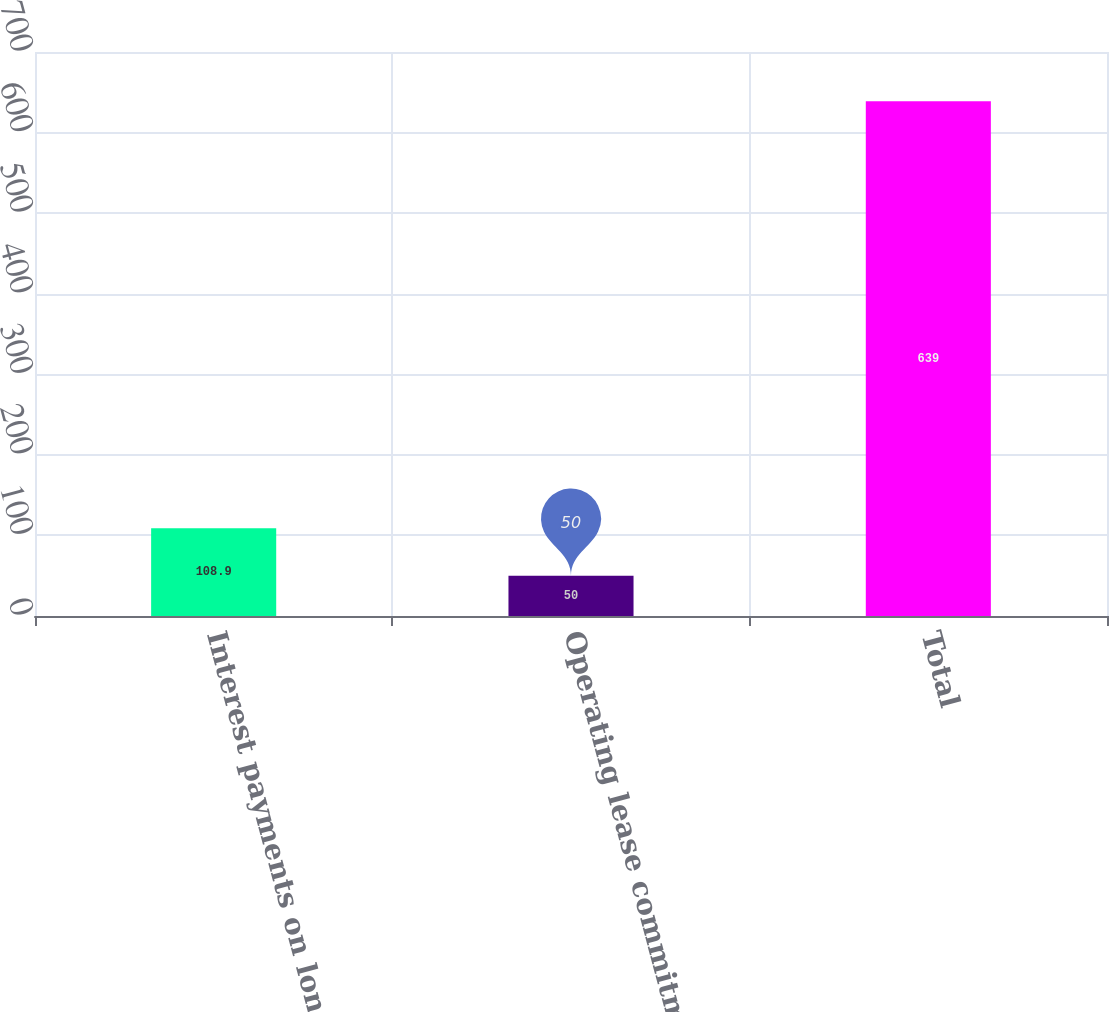Convert chart. <chart><loc_0><loc_0><loc_500><loc_500><bar_chart><fcel>Interest payments on long-term<fcel>Operating lease commitments<fcel>Total<nl><fcel>108.9<fcel>50<fcel>639<nl></chart> 